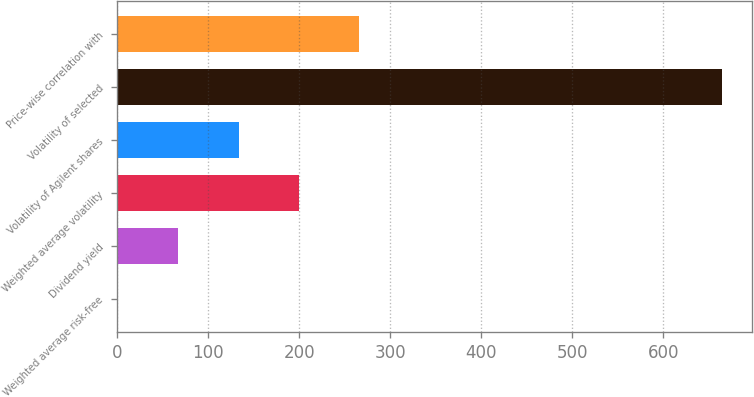Convert chart to OTSL. <chart><loc_0><loc_0><loc_500><loc_500><bar_chart><fcel>Weighted average risk-free<fcel>Dividend yield<fcel>Weighted average volatility<fcel>Volatility of Agilent shares<fcel>Volatility of selected<fcel>Price-wise correlation with<nl><fcel>0.86<fcel>67.17<fcel>199.79<fcel>133.48<fcel>664<fcel>266.1<nl></chart> 